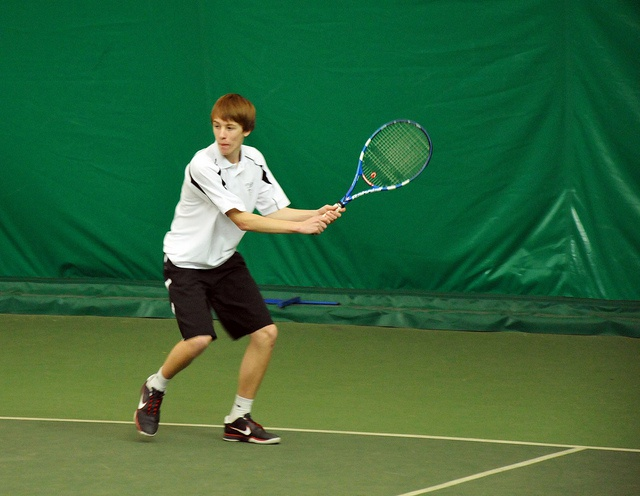Describe the objects in this image and their specific colors. I can see people in darkgreen, white, black, and tan tones and tennis racket in darkgreen and green tones in this image. 